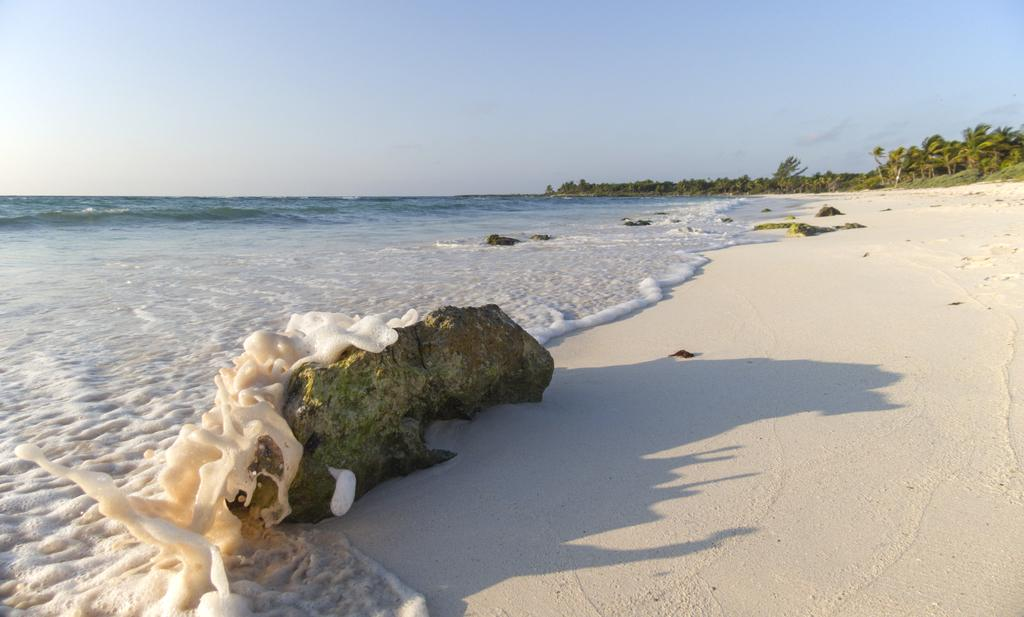What is the main subject of the image? There is a rock in the image. What can be seen on the left side of the image? There is water on the left side of the image. What type of vegetation is visible in the background of the image? There are trees in the background of the image. What is visible at the top of the image? The sky is visible at the top of the image. Can you tell me how many quarters are visible in the image? There are no quarters present in the image. What type of animal can be seen grazing near the rock in the image? There is no animal, such as a goat, present in the image. 